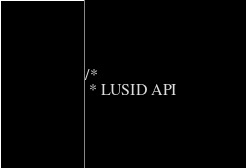Convert code to text. <code><loc_0><loc_0><loc_500><loc_500><_Java_>/*
 * LUSID API</code> 